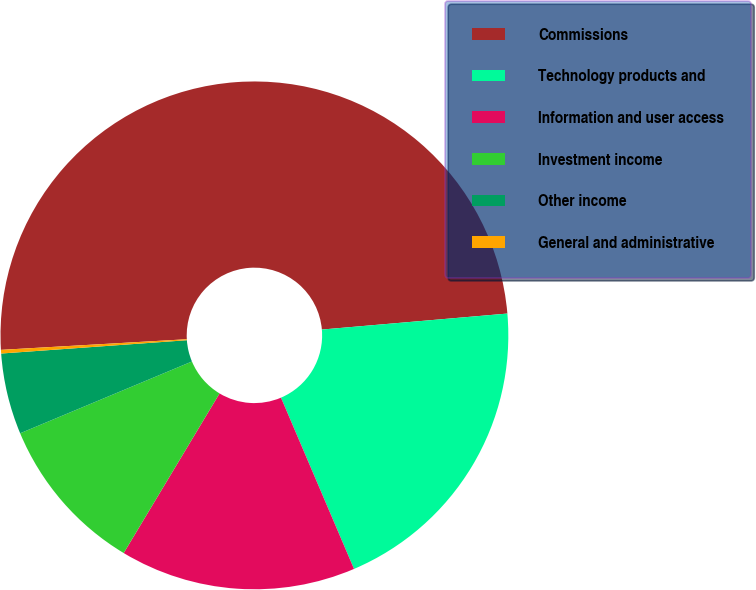Convert chart to OTSL. <chart><loc_0><loc_0><loc_500><loc_500><pie_chart><fcel>Commissions<fcel>Technology products and<fcel>Information and user access<fcel>Investment income<fcel>Other income<fcel>General and administrative<nl><fcel>49.53%<fcel>19.95%<fcel>15.02%<fcel>10.09%<fcel>5.16%<fcel>0.23%<nl></chart> 